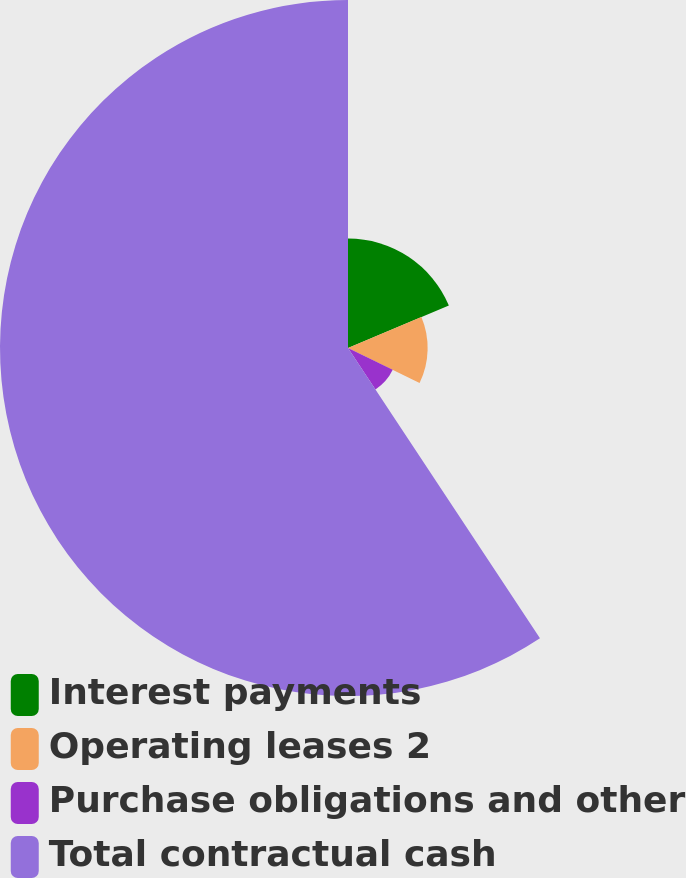Convert chart. <chart><loc_0><loc_0><loc_500><loc_500><pie_chart><fcel>Interest payments<fcel>Operating leases 2<fcel>Purchase obligations and other<fcel>Total contractual cash<nl><fcel>18.65%<fcel>13.57%<fcel>8.48%<fcel>59.3%<nl></chart> 